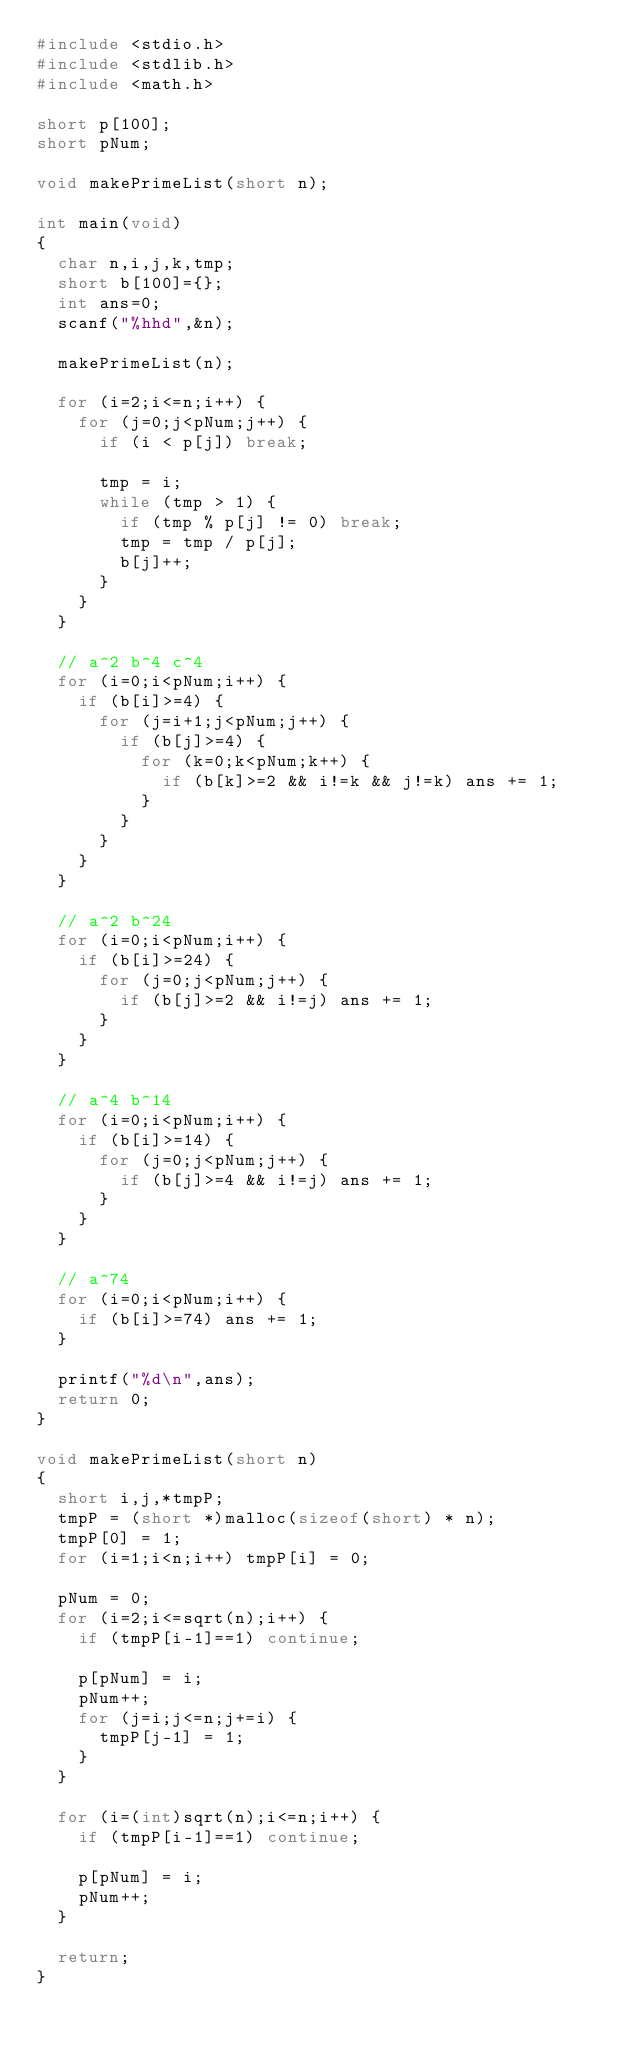Convert code to text. <code><loc_0><loc_0><loc_500><loc_500><_C_>#include <stdio.h>
#include <stdlib.h>
#include <math.h>

short p[100];
short pNum;

void makePrimeList(short n);

int main(void)
{
	char n,i,j,k,tmp;
	short b[100]={};
	int ans=0;
	scanf("%hhd",&n);

	makePrimeList(n);
	
	for (i=2;i<=n;i++) {
		for (j=0;j<pNum;j++) {
			if (i < p[j]) break;
			
			tmp = i;
			while (tmp > 1) {
				if (tmp % p[j] != 0) break;
				tmp = tmp / p[j];
				b[j]++;
			}
		}
	}

	// a^2 b^4 c^4
	for (i=0;i<pNum;i++) {
		if (b[i]>=4) {
			for (j=i+1;j<pNum;j++) {
				if (b[j]>=4) {
					for (k=0;k<pNum;k++) {
						if (b[k]>=2 && i!=k && j!=k) ans += 1;
					}
				}
			}
		}
	}

	// a^2 b^24
	for (i=0;i<pNum;i++) {
		if (b[i]>=24) {
			for (j=0;j<pNum;j++) {
				if (b[j]>=2 && i!=j) ans += 1;
			}
		}
	}

	// a^4 b^14
	for (i=0;i<pNum;i++) {
		if (b[i]>=14) {
			for (j=0;j<pNum;j++) {
				if (b[j]>=4 && i!=j) ans += 1;
			}
		}
	}

	// a^74
	for (i=0;i<pNum;i++) {
		if (b[i]>=74) ans += 1;
	}

	printf("%d\n",ans);
	return 0;
}

void makePrimeList(short n)
{
	short i,j,*tmpP;
	tmpP = (short *)malloc(sizeof(short) * n);
	tmpP[0] = 1;
	for (i=1;i<n;i++) tmpP[i] = 0;

	pNum = 0;
	for (i=2;i<=sqrt(n);i++) {
		if (tmpP[i-1]==1) continue;
		
		p[pNum] = i;
		pNum++;
		for (j=i;j<=n;j+=i) {
			tmpP[j-1] = 1;
		}
	}

	for (i=(int)sqrt(n);i<=n;i++) {
		if (tmpP[i-1]==1) continue;

		p[pNum] = i;
		pNum++;
	}

	return;
}


</code> 